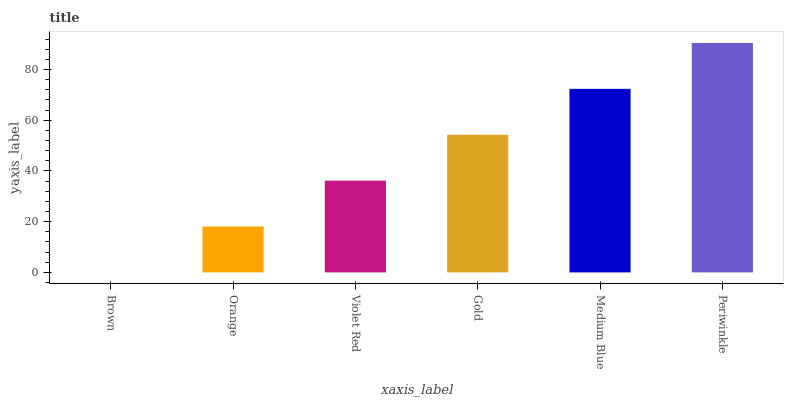Is Brown the minimum?
Answer yes or no. Yes. Is Periwinkle the maximum?
Answer yes or no. Yes. Is Orange the minimum?
Answer yes or no. No. Is Orange the maximum?
Answer yes or no. No. Is Orange greater than Brown?
Answer yes or no. Yes. Is Brown less than Orange?
Answer yes or no. Yes. Is Brown greater than Orange?
Answer yes or no. No. Is Orange less than Brown?
Answer yes or no. No. Is Gold the high median?
Answer yes or no. Yes. Is Violet Red the low median?
Answer yes or no. Yes. Is Violet Red the high median?
Answer yes or no. No. Is Medium Blue the low median?
Answer yes or no. No. 